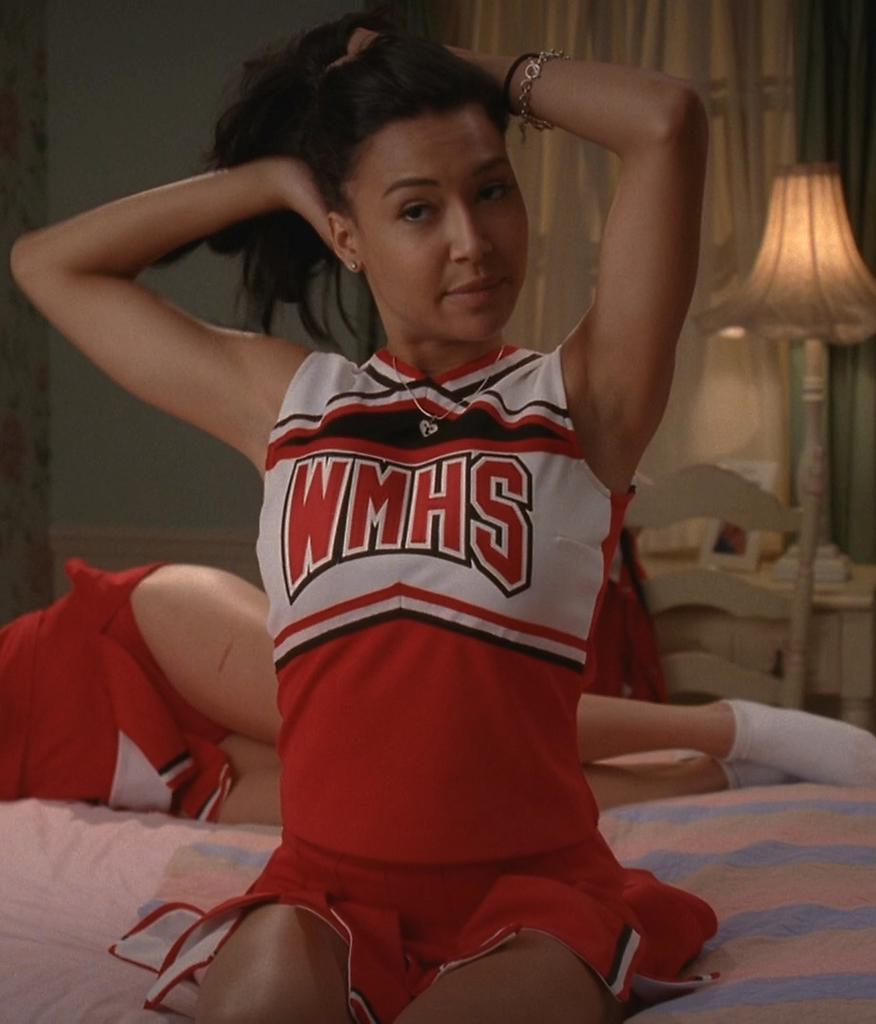<image>
Give a short and clear explanation of the subsequent image. A WMHS cheerleader sits on a bed in her house. 